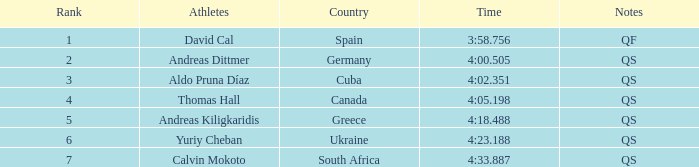What is Andreas Kiligkaridis rank? 5.0. 